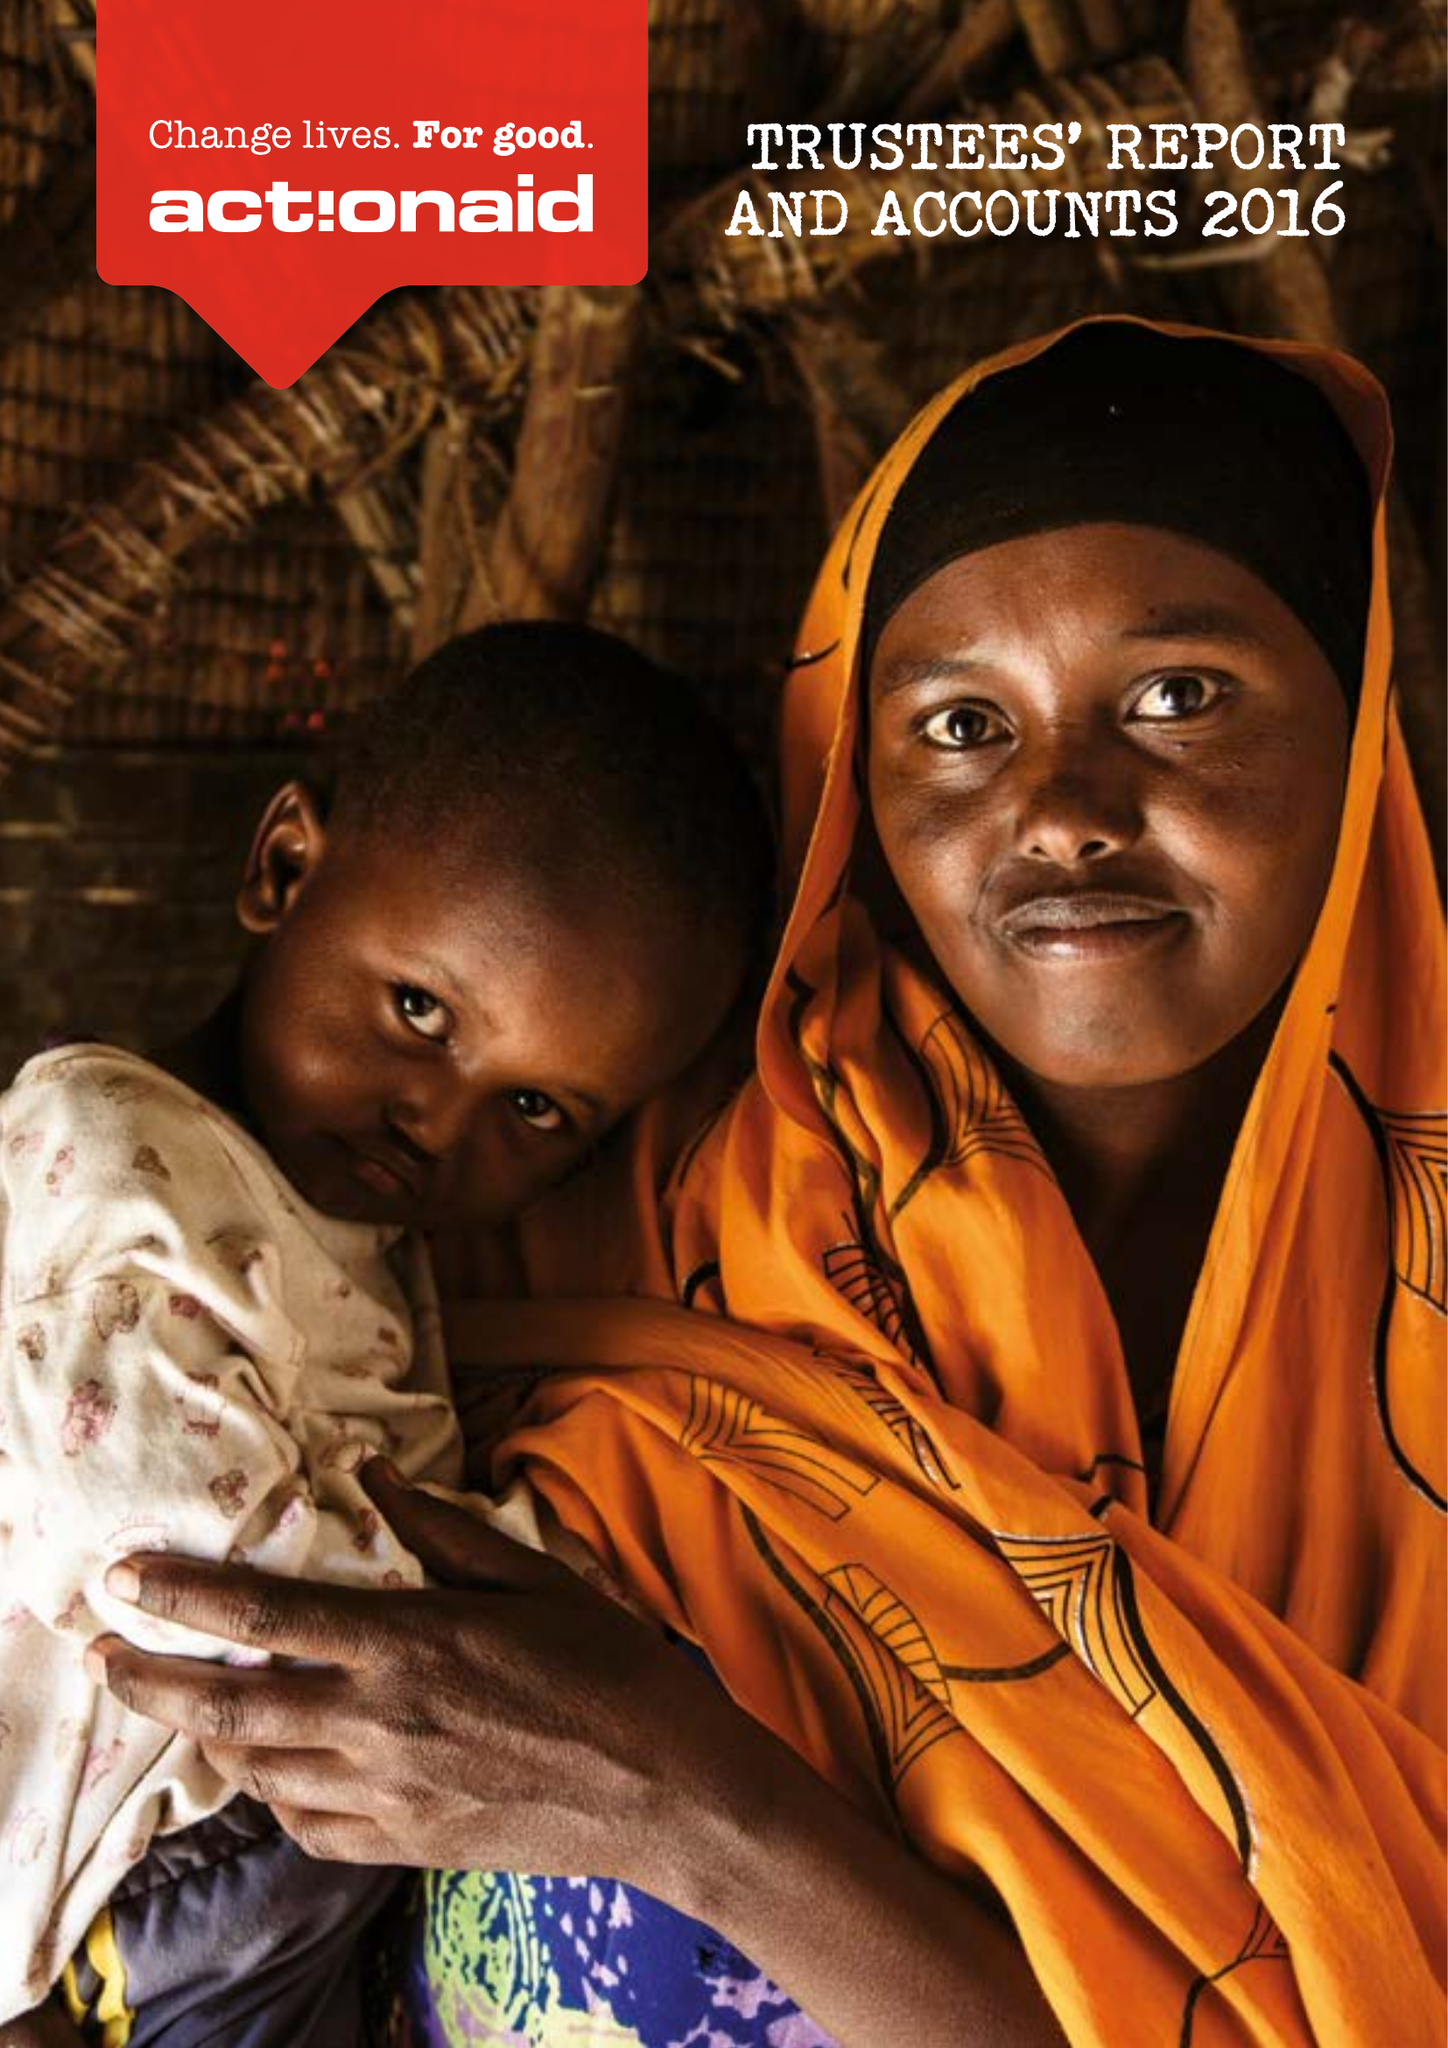What is the value for the address__post_town?
Answer the question using a single word or phrase. LONDON 